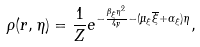<formula> <loc_0><loc_0><loc_500><loc_500>\rho ( { r } , \eta ) = \frac { 1 } { Z } e ^ { - \frac { \beta _ { \xi } \eta ^ { 2 } } { 4 y } - ( \mu _ { \xi } \overline { \xi } + \alpha _ { \xi } ) \eta } ,</formula> 